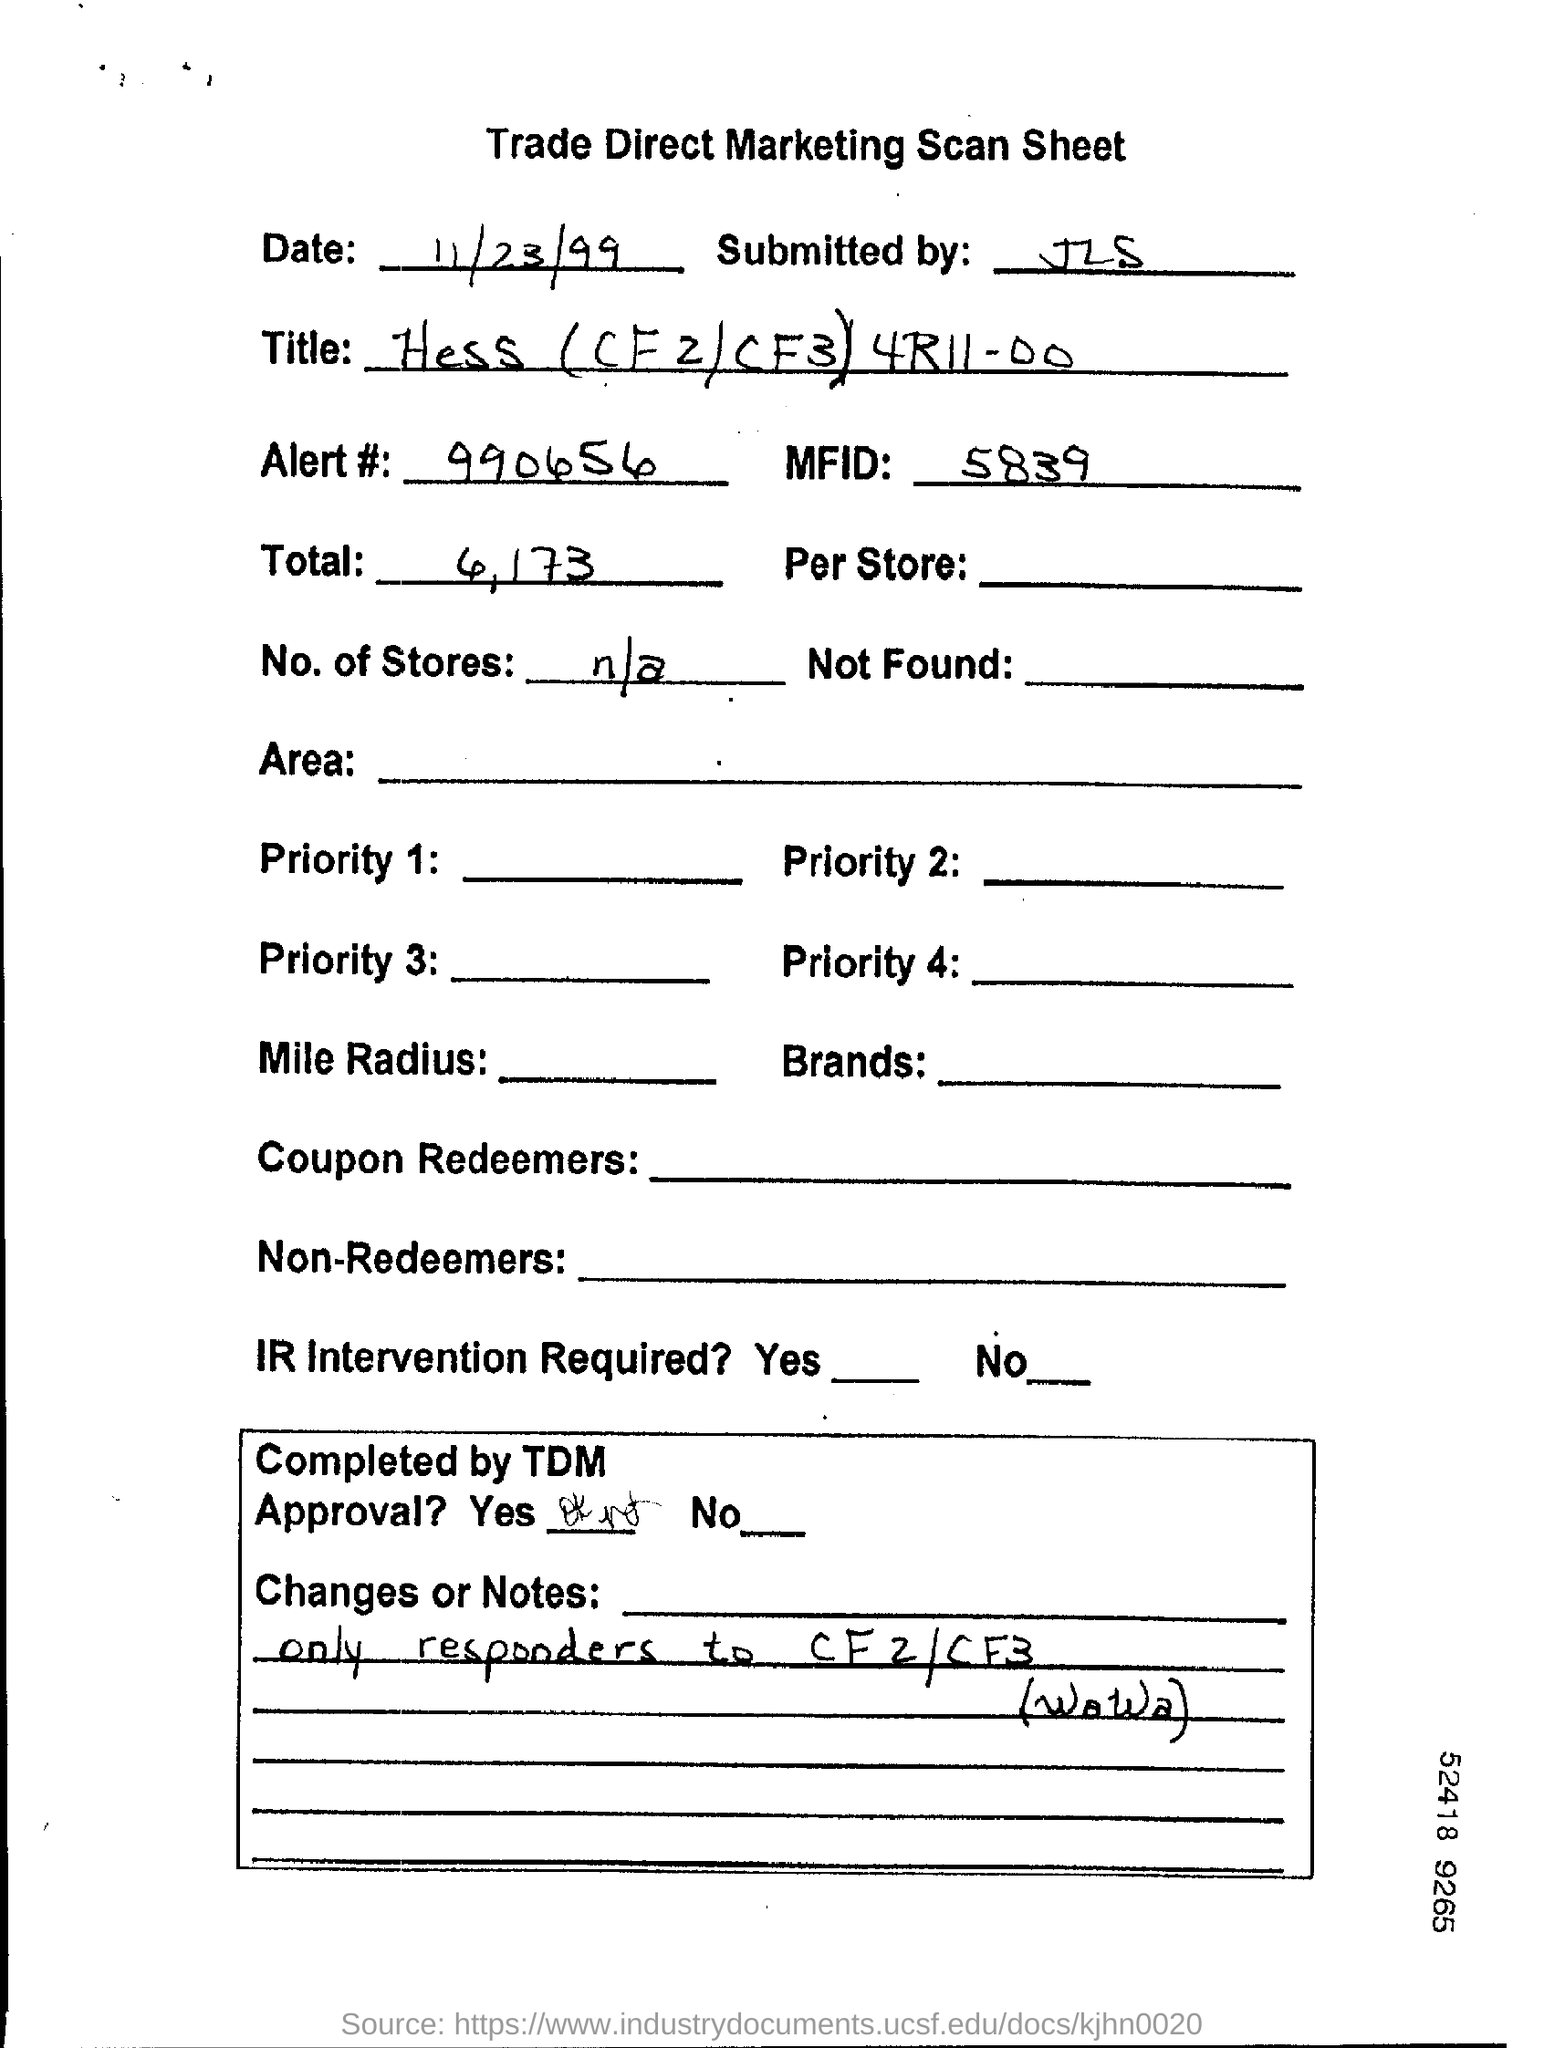Point out several critical features in this image. The document in question is a Trade Direct Marketing Scan Sheet. The alert number provided in the document is 990656. The date referenced in this document is 11/23/99. 